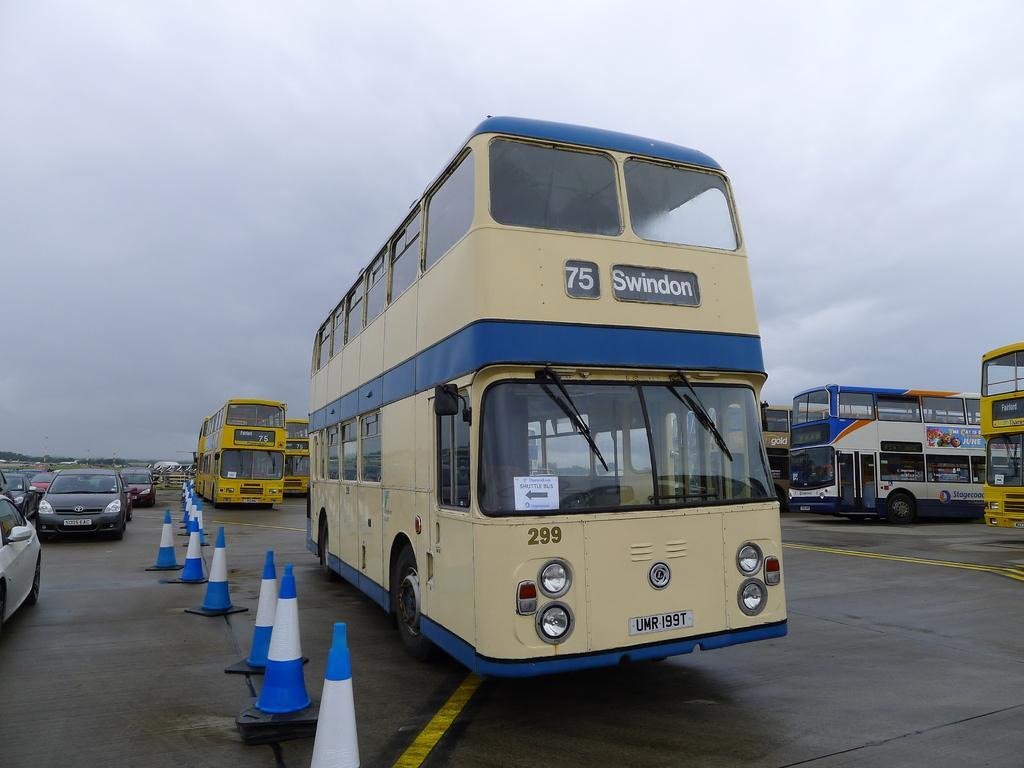Could you give a brief overview of what you see in this image? In this image we can see the vehicles on the road. On few vehicles we can see the text. Beside the vehicles we can see the barriers. At the top we can see the sky. 